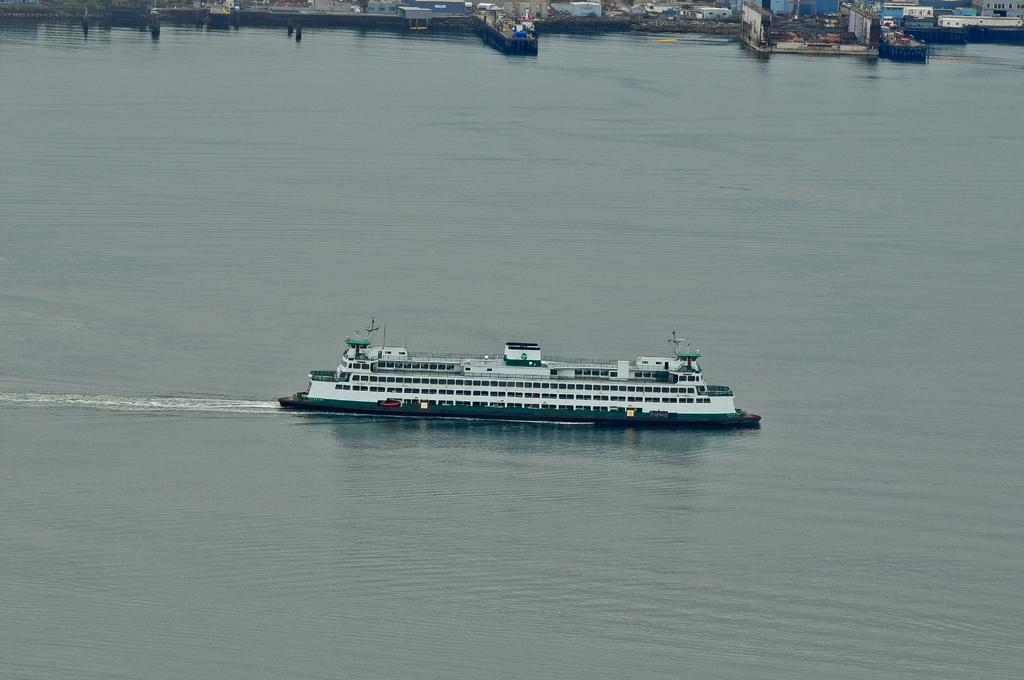What is the main subject of the image? The main subject of the image is a ship. Where is the ship located in the image? The ship is on the water in the image. What colors can be seen on the ship? The ship is in white and green color. What can be seen in the background of the image? There are buildings in the background of the image. How much profit does the kettle generate in the image? There is no kettle present in the image, so it is not possible to determine any profit generated. 